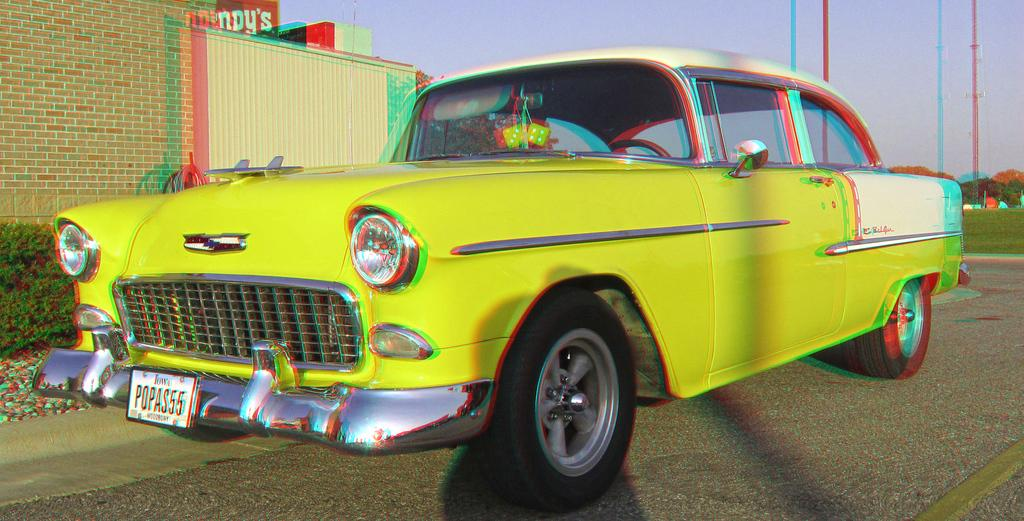<image>
Summarize the visual content of the image. an Iowa license plate on a big yellow car 